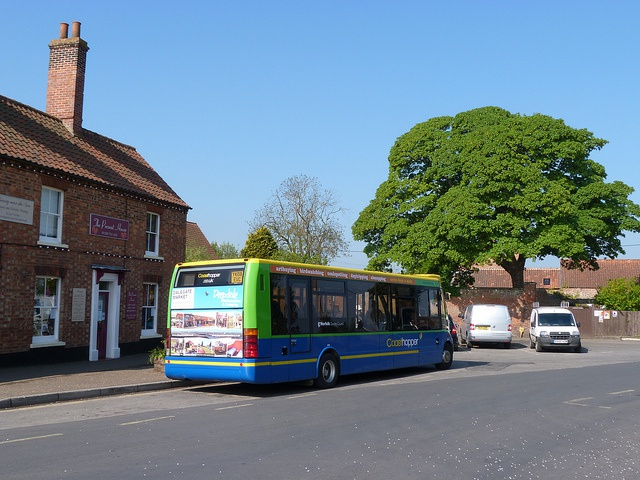Describe the objects in this image and their specific colors. I can see bus in lightblue, black, navy, white, and gray tones, truck in lightblue, white, gray, black, and darkblue tones, car in lightblue, white, darkgray, gray, and black tones, and car in lightblue, black, darkgray, and gray tones in this image. 